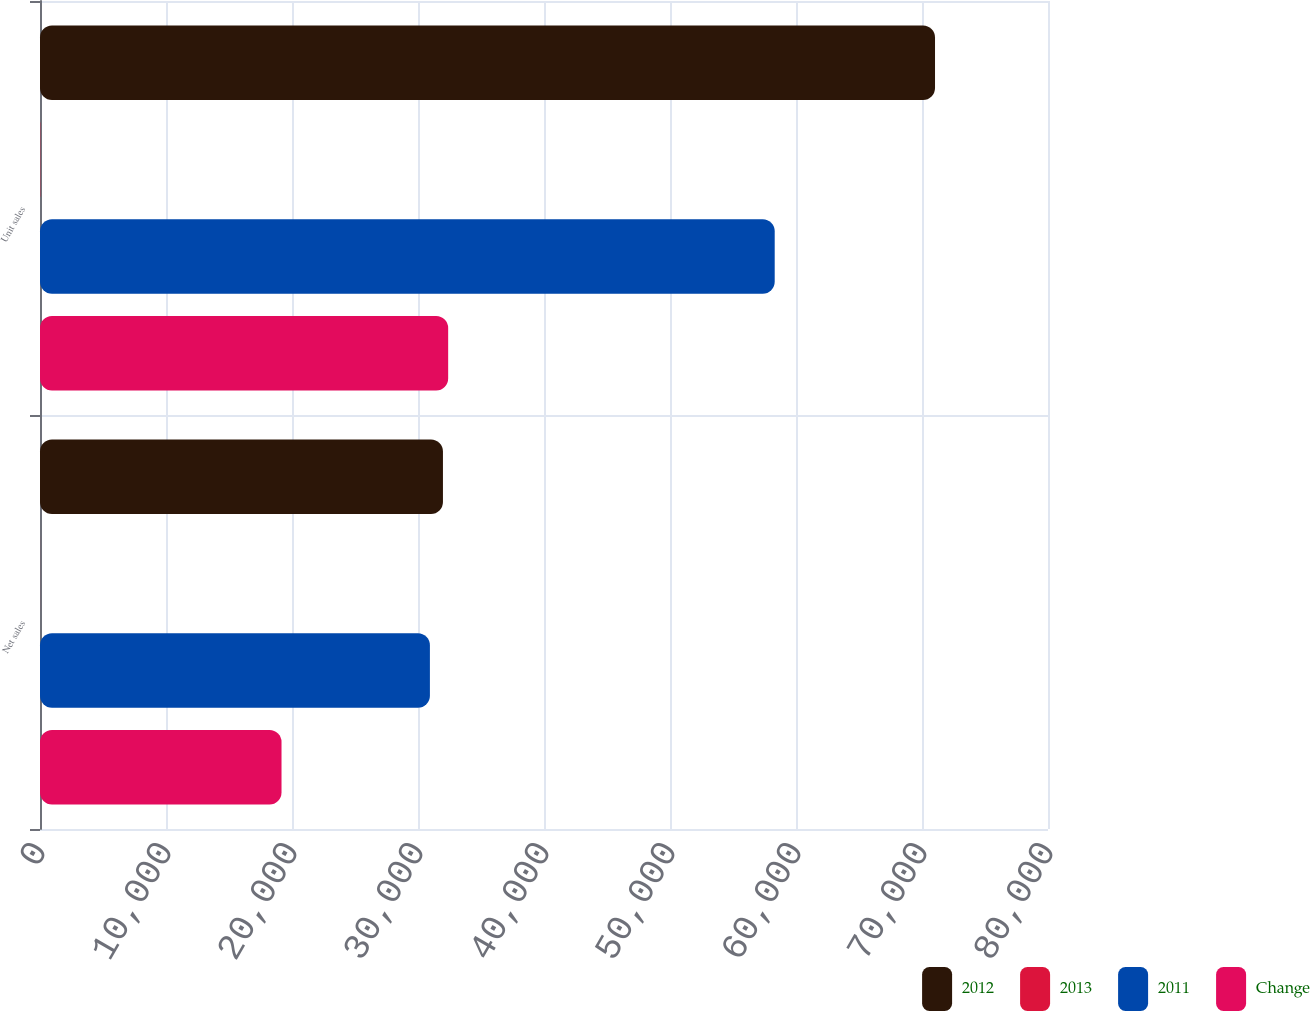Convert chart. <chart><loc_0><loc_0><loc_500><loc_500><stacked_bar_chart><ecel><fcel>Net sales<fcel>Unit sales<nl><fcel>2012<fcel>31980<fcel>71033<nl><fcel>2013<fcel>3<fcel>22<nl><fcel>2011<fcel>30945<fcel>58310<nl><fcel>Change<fcel>19168<fcel>32394<nl></chart> 